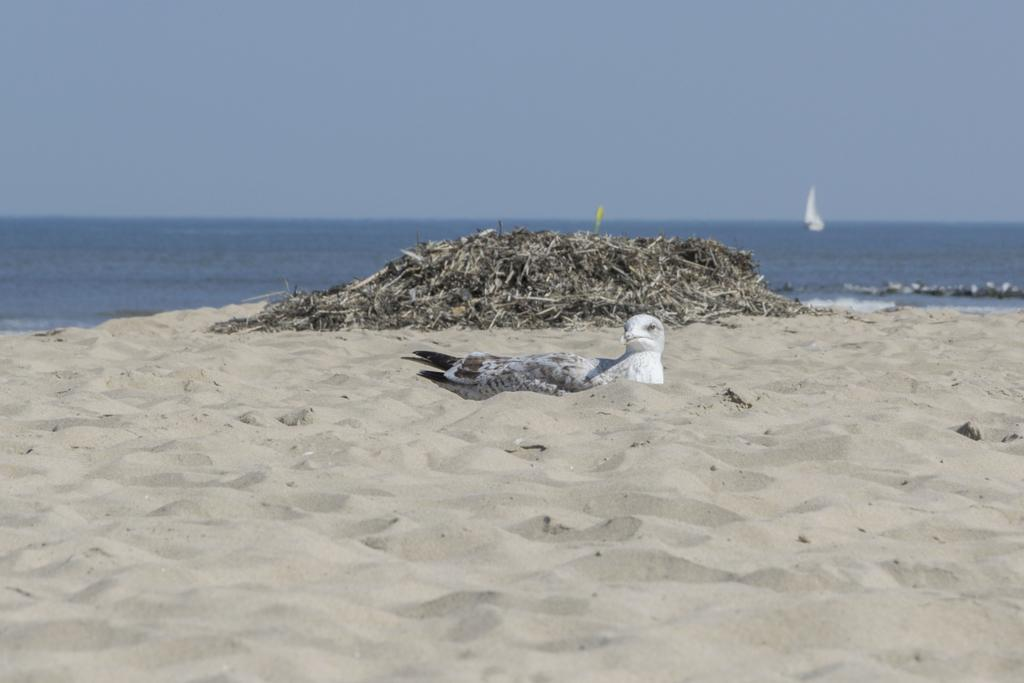What type of animal can be seen on the sand in the image? There is a bird on the sand in the image. What type of waste is visible in the image? There is garbage visible in the image. What type of vehicle is on the water in the image? There is a boat on the water in the image. What is visible at the top of the image? The sky is visible at the top of the image. What type of terrain is at the bottom of the image? There is sand at the bottom of the image. What type of liquid is visible at the bottom of the image? There is water visible at the bottom of the image. What type of eggs can be seen in the image? There are no eggs present in the image. What type of brass object can be seen in the image? There is no brass object present in the image. 